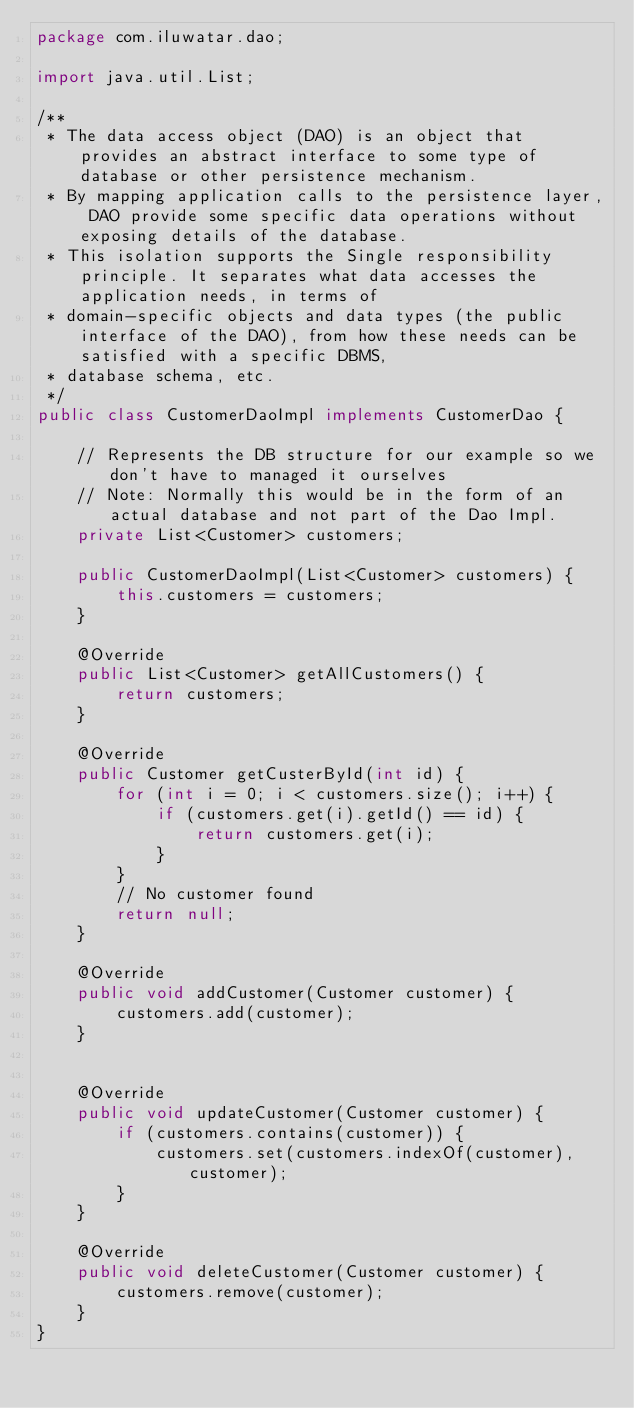<code> <loc_0><loc_0><loc_500><loc_500><_Java_>package com.iluwatar.dao;

import java.util.List;

/**
 * The data access object (DAO) is an object that provides an abstract interface to some type of database or other persistence mechanism.
 * By mapping application calls to the persistence layer, DAO provide some specific data operations without exposing details of the database.
 * This isolation supports the Single responsibility principle. It separates what data accesses the application needs, in terms of
 * domain-specific objects and data types (the public interface of the DAO), from how these needs can be satisfied with a specific DBMS,
 * database schema, etc.
 */
public class CustomerDaoImpl implements CustomerDao {

    // Represents the DB structure for our example so we don't have to managed it ourselves
    // Note: Normally this would be in the form of an actual database and not part of the Dao Impl.
    private List<Customer> customers;

    public CustomerDaoImpl(List<Customer> customers) {
        this.customers = customers;
    }

    @Override
    public List<Customer> getAllCustomers() {
        return customers;
    }

    @Override
    public Customer getCusterById(int id) {
        for (int i = 0; i < customers.size(); i++) {
            if (customers.get(i).getId() == id) {
                return customers.get(i);
            }
        }
        // No customer found
        return null;
    }

    @Override
    public void addCustomer(Customer customer) {
        customers.add(customer);
    }


    @Override
    public void updateCustomer(Customer customer) {
        if (customers.contains(customer)) {
            customers.set(customers.indexOf(customer), customer);
        }
    }

    @Override
    public void deleteCustomer(Customer customer) {
        customers.remove(customer);
    }
}</code> 